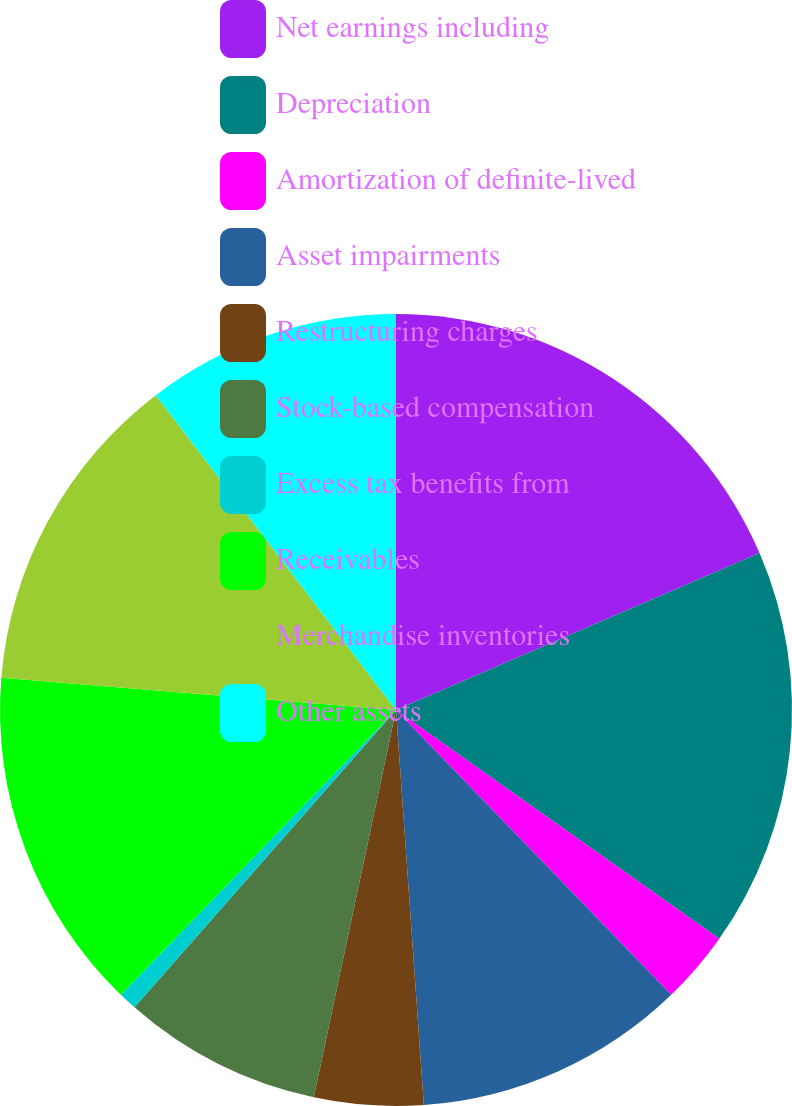Convert chart to OTSL. <chart><loc_0><loc_0><loc_500><loc_500><pie_chart><fcel>Net earnings including<fcel>Depreciation<fcel>Amortization of definite-lived<fcel>Asset impairments<fcel>Restructuring charges<fcel>Stock-based compensation<fcel>Excess tax benefits from<fcel>Receivables<fcel>Merchandise inventories<fcel>Other assets<nl><fcel>18.51%<fcel>16.29%<fcel>2.97%<fcel>11.11%<fcel>4.45%<fcel>8.15%<fcel>0.75%<fcel>14.07%<fcel>13.33%<fcel>10.37%<nl></chart> 